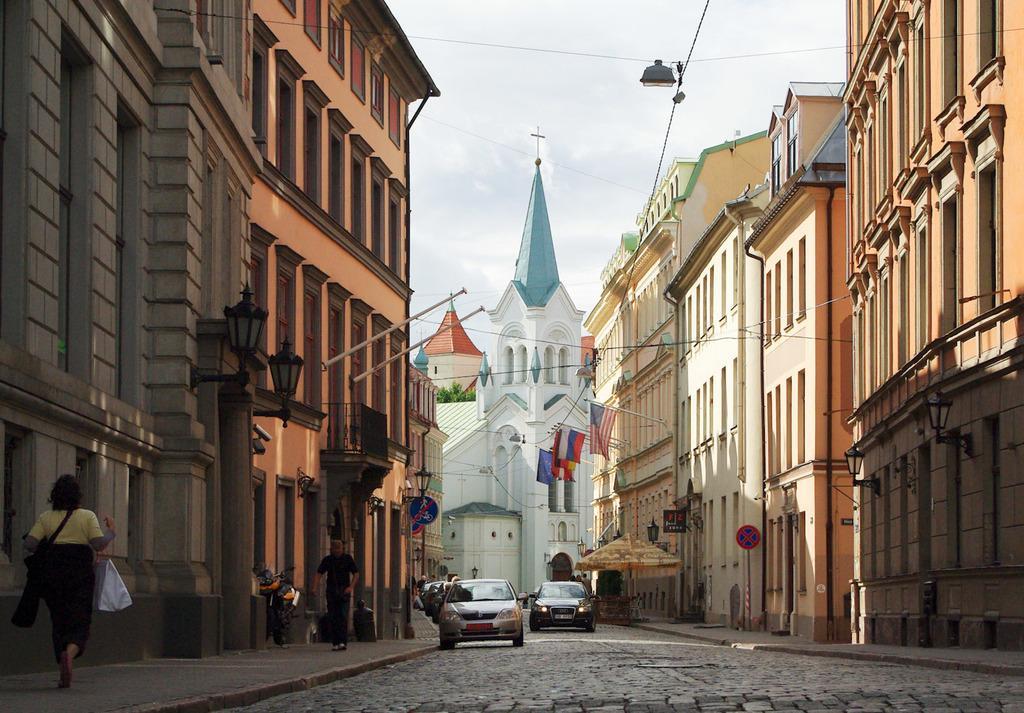Please provide a concise description of this image. In the center of the image we can see the towers. In the background of the image we can see the buildings, windows, wires, lights. At the bottom of the image we can see the cars, road, tent, boards, poles, balcony and people. On the left side of the image we can see a lady is walking on the footpath and carrying bags. At the top of the image we can see the clouds are present in the sky. 